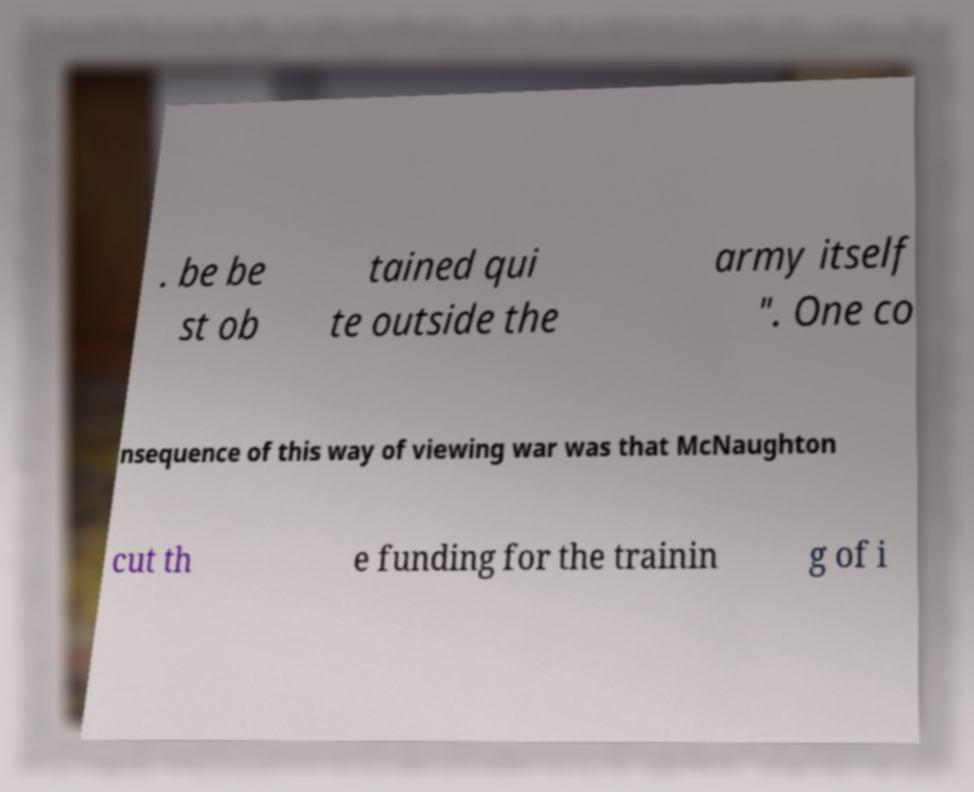Could you assist in decoding the text presented in this image and type it out clearly? . be be st ob tained qui te outside the army itself ". One co nsequence of this way of viewing war was that McNaughton cut th e funding for the trainin g of i 